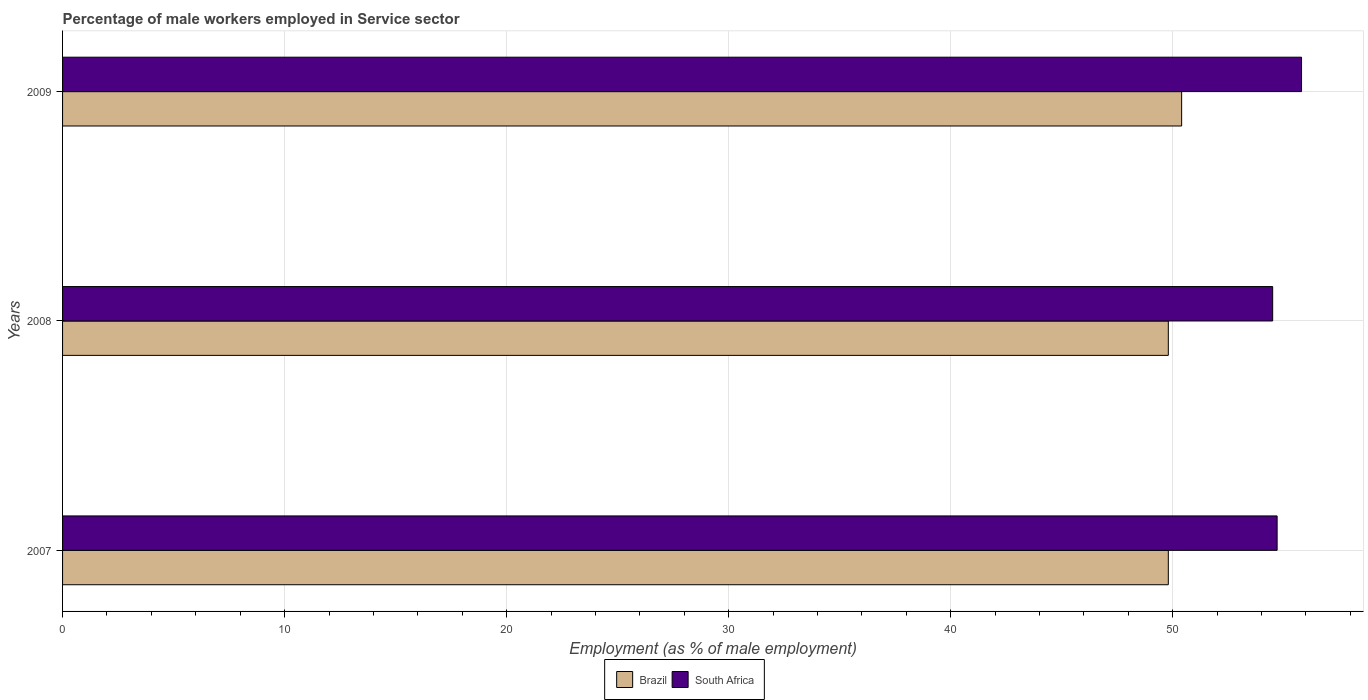How many different coloured bars are there?
Ensure brevity in your answer.  2. Are the number of bars per tick equal to the number of legend labels?
Your response must be concise. Yes. How many bars are there on the 2nd tick from the bottom?
Your answer should be compact. 2. What is the label of the 3rd group of bars from the top?
Make the answer very short. 2007. What is the percentage of male workers employed in Service sector in South Africa in 2009?
Offer a very short reply. 55.8. Across all years, what is the maximum percentage of male workers employed in Service sector in Brazil?
Provide a succinct answer. 50.4. Across all years, what is the minimum percentage of male workers employed in Service sector in Brazil?
Give a very brief answer. 49.8. What is the total percentage of male workers employed in Service sector in Brazil in the graph?
Your response must be concise. 150. What is the difference between the percentage of male workers employed in Service sector in South Africa in 2007 and that in 2009?
Your answer should be compact. -1.1. What is the difference between the percentage of male workers employed in Service sector in South Africa in 2009 and the percentage of male workers employed in Service sector in Brazil in 2007?
Your answer should be very brief. 6. What is the average percentage of male workers employed in Service sector in Brazil per year?
Keep it short and to the point. 50. In the year 2009, what is the difference between the percentage of male workers employed in Service sector in South Africa and percentage of male workers employed in Service sector in Brazil?
Offer a terse response. 5.4. What is the ratio of the percentage of male workers employed in Service sector in South Africa in 2007 to that in 2008?
Offer a terse response. 1. Is the percentage of male workers employed in Service sector in South Africa in 2007 less than that in 2008?
Your answer should be very brief. No. What is the difference between the highest and the second highest percentage of male workers employed in Service sector in South Africa?
Offer a terse response. 1.1. What is the difference between the highest and the lowest percentage of male workers employed in Service sector in Brazil?
Ensure brevity in your answer.  0.6. What does the 1st bar from the top in 2008 represents?
Ensure brevity in your answer.  South Africa. What does the 1st bar from the bottom in 2008 represents?
Provide a succinct answer. Brazil. Are all the bars in the graph horizontal?
Offer a very short reply. Yes. How many years are there in the graph?
Give a very brief answer. 3. Are the values on the major ticks of X-axis written in scientific E-notation?
Offer a terse response. No. How are the legend labels stacked?
Offer a terse response. Horizontal. What is the title of the graph?
Give a very brief answer. Percentage of male workers employed in Service sector. Does "Dominica" appear as one of the legend labels in the graph?
Provide a short and direct response. No. What is the label or title of the X-axis?
Your answer should be very brief. Employment (as % of male employment). What is the Employment (as % of male employment) in Brazil in 2007?
Offer a terse response. 49.8. What is the Employment (as % of male employment) in South Africa in 2007?
Give a very brief answer. 54.7. What is the Employment (as % of male employment) of Brazil in 2008?
Keep it short and to the point. 49.8. What is the Employment (as % of male employment) in South Africa in 2008?
Provide a short and direct response. 54.5. What is the Employment (as % of male employment) in Brazil in 2009?
Your answer should be compact. 50.4. What is the Employment (as % of male employment) in South Africa in 2009?
Provide a succinct answer. 55.8. Across all years, what is the maximum Employment (as % of male employment) of Brazil?
Your answer should be very brief. 50.4. Across all years, what is the maximum Employment (as % of male employment) of South Africa?
Offer a very short reply. 55.8. Across all years, what is the minimum Employment (as % of male employment) of Brazil?
Offer a terse response. 49.8. Across all years, what is the minimum Employment (as % of male employment) in South Africa?
Your answer should be very brief. 54.5. What is the total Employment (as % of male employment) of Brazil in the graph?
Keep it short and to the point. 150. What is the total Employment (as % of male employment) in South Africa in the graph?
Your answer should be very brief. 165. What is the difference between the Employment (as % of male employment) in Brazil in 2007 and that in 2008?
Ensure brevity in your answer.  0. What is the difference between the Employment (as % of male employment) of South Africa in 2007 and that in 2009?
Provide a succinct answer. -1.1. What is the difference between the Employment (as % of male employment) of Brazil in 2008 and that in 2009?
Ensure brevity in your answer.  -0.6. What is the difference between the Employment (as % of male employment) in Brazil in 2007 and the Employment (as % of male employment) in South Africa in 2009?
Provide a short and direct response. -6. What is the difference between the Employment (as % of male employment) of Brazil in 2008 and the Employment (as % of male employment) of South Africa in 2009?
Your response must be concise. -6. What is the average Employment (as % of male employment) of South Africa per year?
Ensure brevity in your answer.  55. In the year 2008, what is the difference between the Employment (as % of male employment) of Brazil and Employment (as % of male employment) of South Africa?
Keep it short and to the point. -4.7. What is the ratio of the Employment (as % of male employment) in Brazil in 2007 to that in 2008?
Offer a very short reply. 1. What is the ratio of the Employment (as % of male employment) in South Africa in 2007 to that in 2008?
Ensure brevity in your answer.  1. What is the ratio of the Employment (as % of male employment) in South Africa in 2007 to that in 2009?
Keep it short and to the point. 0.98. What is the ratio of the Employment (as % of male employment) in Brazil in 2008 to that in 2009?
Your response must be concise. 0.99. What is the ratio of the Employment (as % of male employment) in South Africa in 2008 to that in 2009?
Provide a short and direct response. 0.98. 